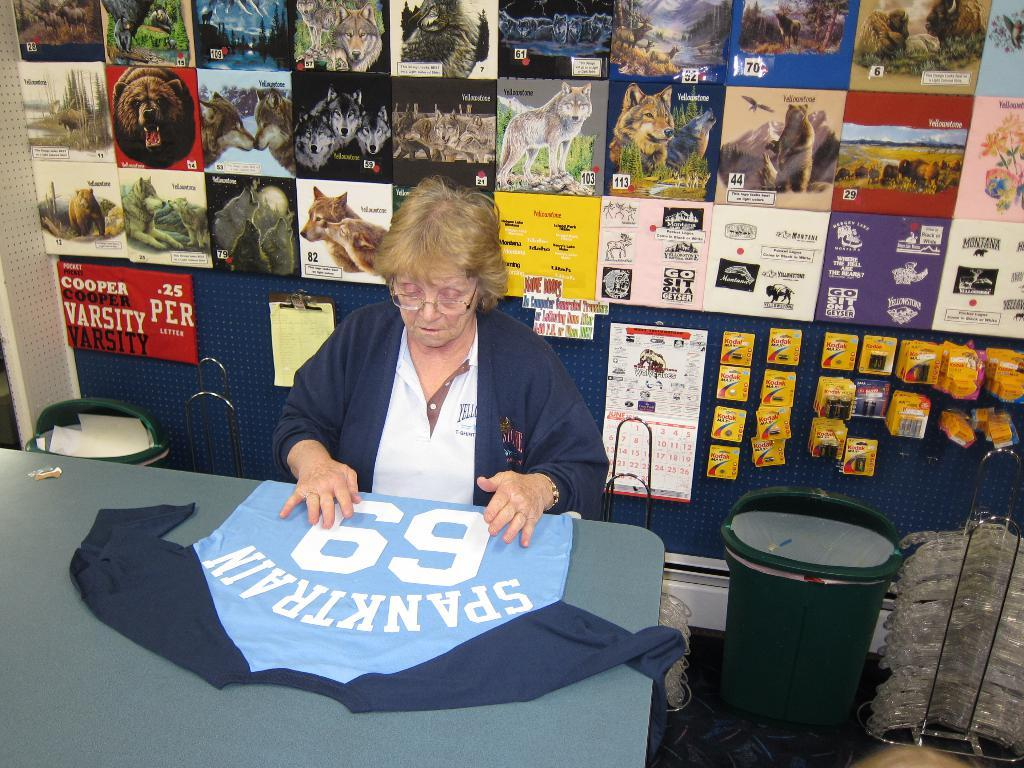<image>
Provide a brief description of the given image. A woman at a table has a sexual worded shirt in front of her. 